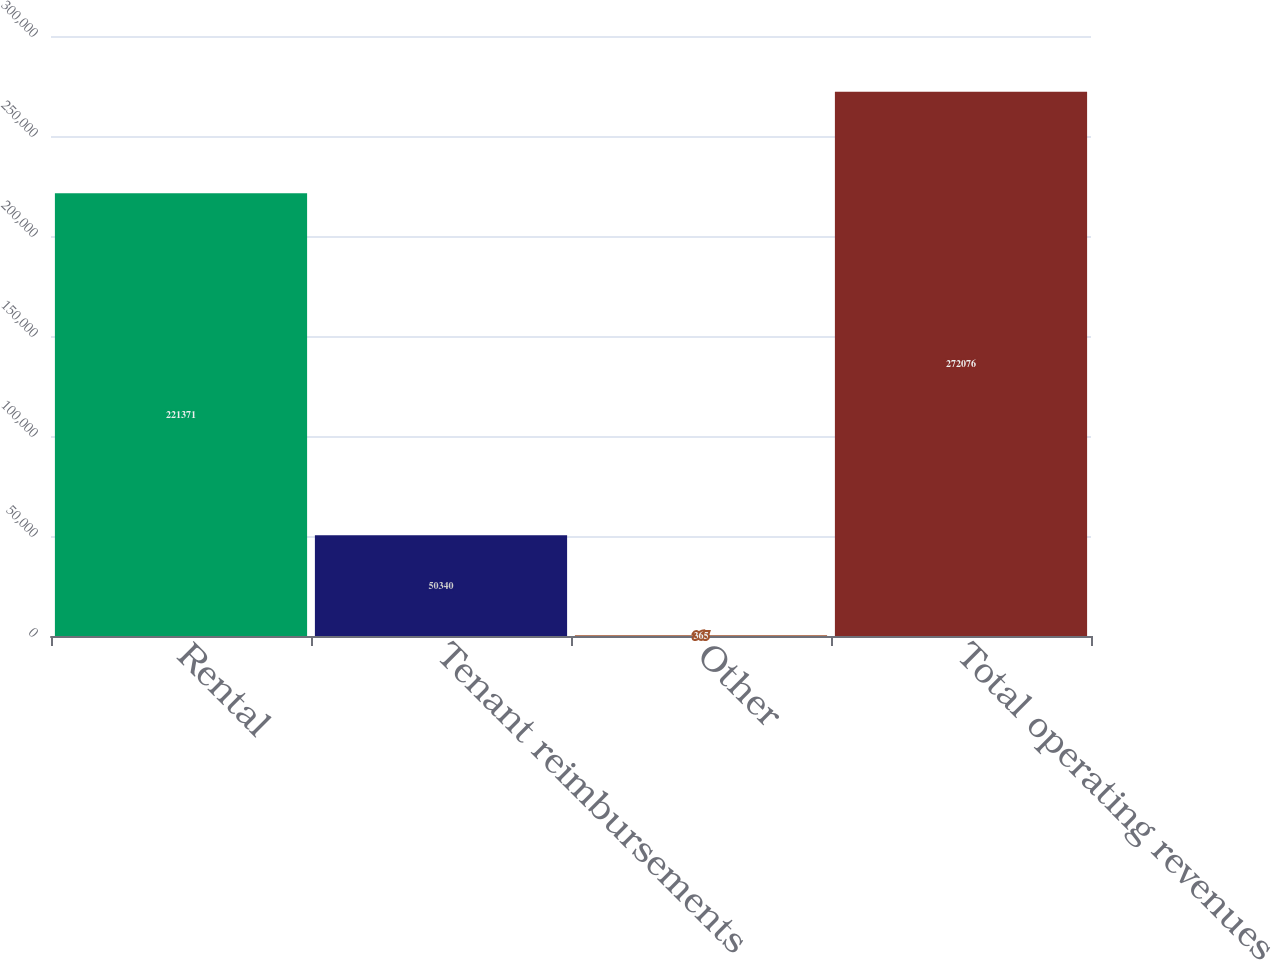Convert chart. <chart><loc_0><loc_0><loc_500><loc_500><bar_chart><fcel>Rental<fcel>Tenant reimbursements<fcel>Other<fcel>Total operating revenues<nl><fcel>221371<fcel>50340<fcel>365<fcel>272076<nl></chart> 